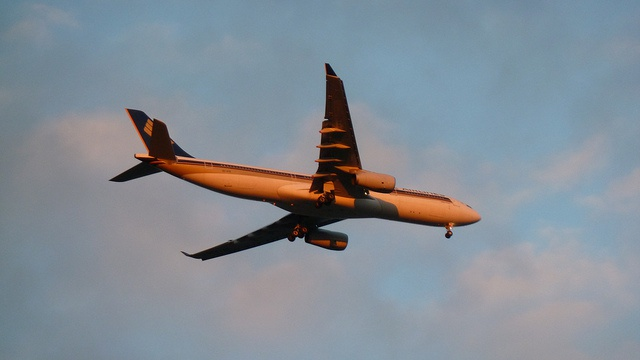Describe the objects in this image and their specific colors. I can see a airplane in gray, black, brown, maroon, and salmon tones in this image. 